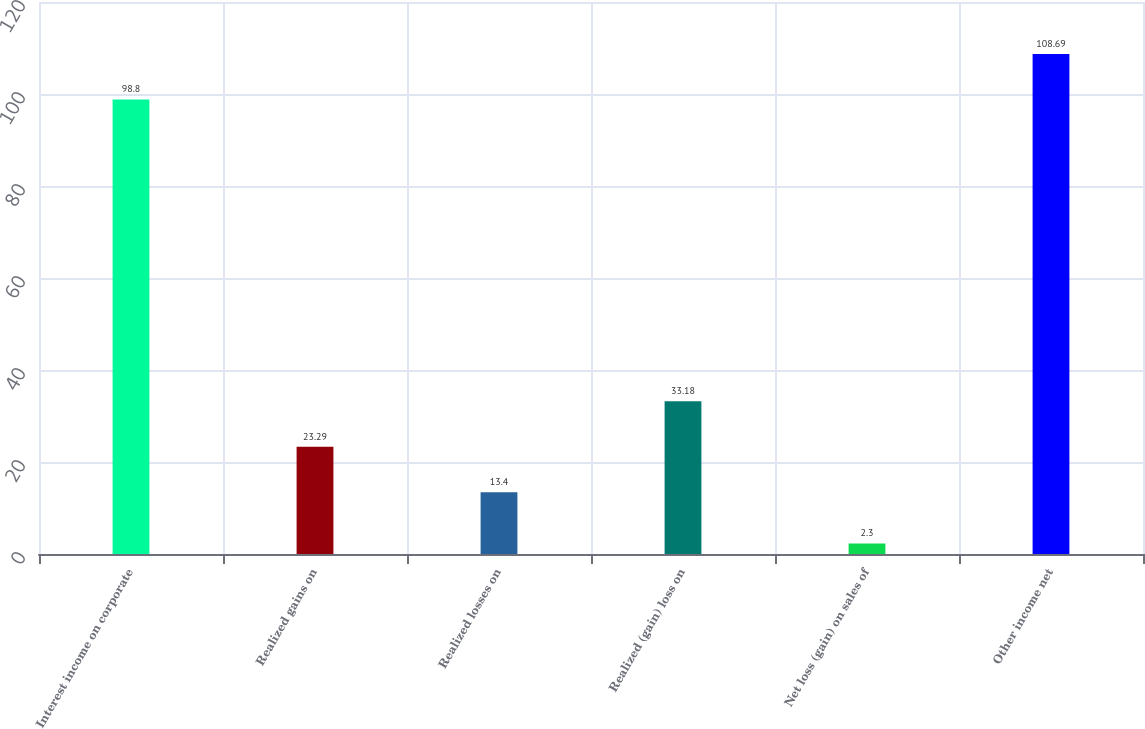Convert chart to OTSL. <chart><loc_0><loc_0><loc_500><loc_500><bar_chart><fcel>Interest income on corporate<fcel>Realized gains on<fcel>Realized losses on<fcel>Realized (gain) loss on<fcel>Net loss (gain) on sales of<fcel>Other income net<nl><fcel>98.8<fcel>23.29<fcel>13.4<fcel>33.18<fcel>2.3<fcel>108.69<nl></chart> 